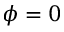Convert formula to latex. <formula><loc_0><loc_0><loc_500><loc_500>{ \phi } = 0</formula> 